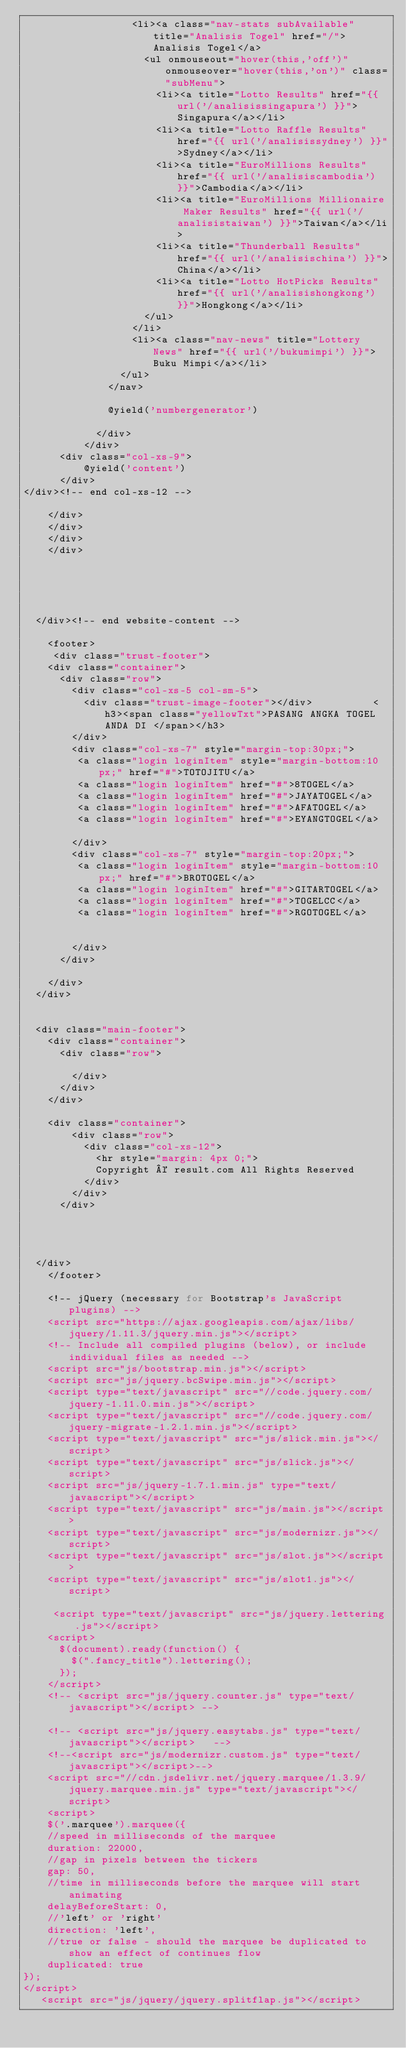Convert code to text. <code><loc_0><loc_0><loc_500><loc_500><_PHP_>                  <li><a class="nav-stats subAvailable" title="Analisis Togel" href="/">Analisis Togel</a>
                    <ul onmouseout="hover(this,'off')" onmouseover="hover(this,'on')" class="subMenu">
                      <li><a title="Lotto Results" href="{{ url('/analisissingapura') }}">Singapura</a></li>
                      <li><a title="Lotto Raffle Results" href="{{ url('/analisissydney') }}">Sydney</a></li>
                      <li><a title="EuroMillions Results" href="{{ url('/analisiscambodia') }}">Cambodia</a></li>
                      <li><a title="EuroMillions Millionaire Maker Results" href="{{ url('/analisistaiwan') }}">Taiwan</a></li>
                      <li><a title="Thunderball Results" href="{{ url('/analisischina') }}">China</a></li>
                      <li><a title="Lotto HotPicks Results" href="{{ url('/analisishongkong') }}">Hongkong</a></li>
                    </ul>
                  </li>
                  <li><a class="nav-news" title="Lottery News" href="{{ url('/bukumimpi') }}">Buku Mimpi</a></li>
                </ul>
              </nav>
  
              @yield('numbergenerator')

            </div>
          </div>
      <div class="col-xs-9">
          @yield('content')
      </div>
</div><!-- end col-xs-12 -->

    </div>
    </div>
    </div>
    </div>
           

            


  </div><!-- end website-content -->

    <footer>
     <div class="trust-footer">
    <div class="container">
      <div class="row">
        <div class="col-xs-5 col-sm-5">
          <div class="trust-image-footer"></div>          <h3><span class="yellowTxt">PASANG ANGKA TOGEL ANDA DI </span></h3>
        </div>
        <div class="col-xs-7" style="margin-top:30px;">
         <a class="login loginItem" style="margin-bottom:10px;" href="#">TOTOJITU</a>
         <a class="login loginItem" href="#">8TOGEL</a>
         <a class="login loginItem" href="#">JAYATOGEL</a>
         <a class="login loginItem" href="#">AFATOGEL</a>
         <a class="login loginItem" href="#">EYANGTOGEL</a>
         
        </div>
        <div class="col-xs-7" style="margin-top:20px;">
         <a class="login loginItem" style="margin-bottom:10px;" href="#">BROTOGEL</a>
         <a class="login loginItem" href="#">GITARTOGEL</a>
         <a class="login loginItem" href="#">TOGELCC</a>
         <a class="login loginItem" href="#">RGOTOGEL</a>
         
         
        </div>
      </div>
      
    </div>
  </div>


  <div class="main-footer">
    <div class="container">
      <div class="row">
      
        </div>
      </div>
    </div>

    <div class="container">
        <div class="row">
          <div class="col-xs-12">
            <hr style="margin: 4px 0;">
            Copyright © result.com All Rights Reserved
          </div>
        </div>
      </div>

  
    

  </div>
    </footer>

    <!-- jQuery (necessary for Bootstrap's JavaScript plugins) -->
    <script src="https://ajax.googleapis.com/ajax/libs/jquery/1.11.3/jquery.min.js"></script>
    <!-- Include all compiled plugins (below), or include individual files as needed -->
    <script src="js/bootstrap.min.js"></script>
    <script src="js/jquery.bcSwipe.min.js"></script>
    <script type="text/javascript" src="//code.jquery.com/jquery-1.11.0.min.js"></script>
    <script type="text/javascript" src="//code.jquery.com/jquery-migrate-1.2.1.min.js"></script>
    <script type="text/javascript" src="js/slick.min.js"></script>
    <script type="text/javascript" src="js/slick.js"></script>
    <script src="js/jquery-1.7.1.min.js" type="text/javascript"></script> 
    <script type="text/javascript" src="js/main.js"></script>
    <script type="text/javascript" src="js/modernizr.js"></script>
    <script type="text/javascript" src="js/slot.js"></script>
    <script type="text/javascript" src="js/slot1.js"></script>
    
     <script type="text/javascript" src="js/jquery.lettering.js"></script>
    <script>
      $(document).ready(function() {
        $(".fancy_title").lettering();
      });
    </script>
    <!-- <script src="js/jquery.counter.js" type="text/javascript"></script> -->

    <!-- <script src="js/jquery.easytabs.js" type="text/javascript"></script>   -->
    <!--<script src="js/modernizr.custom.js" type="text/javascript"></script>-->
    <script src="//cdn.jsdelivr.net/jquery.marquee/1.3.9/jquery.marquee.min.js" type="text/javascript"></script>
    <script>
    $('.marquee').marquee({
    //speed in milliseconds of the marquee
    duration: 22000,
    //gap in pixels between the tickers
    gap: 50,
    //time in milliseconds before the marquee will start animating
    delayBeforeStart: 0,
    //'left' or 'right'
    direction: 'left',
    //true or false - should the marquee be duplicated to show an effect of continues flow
    duplicated: true
});
</script>
   <script src="js/jquery/jquery.splitflap.js"></script></code> 